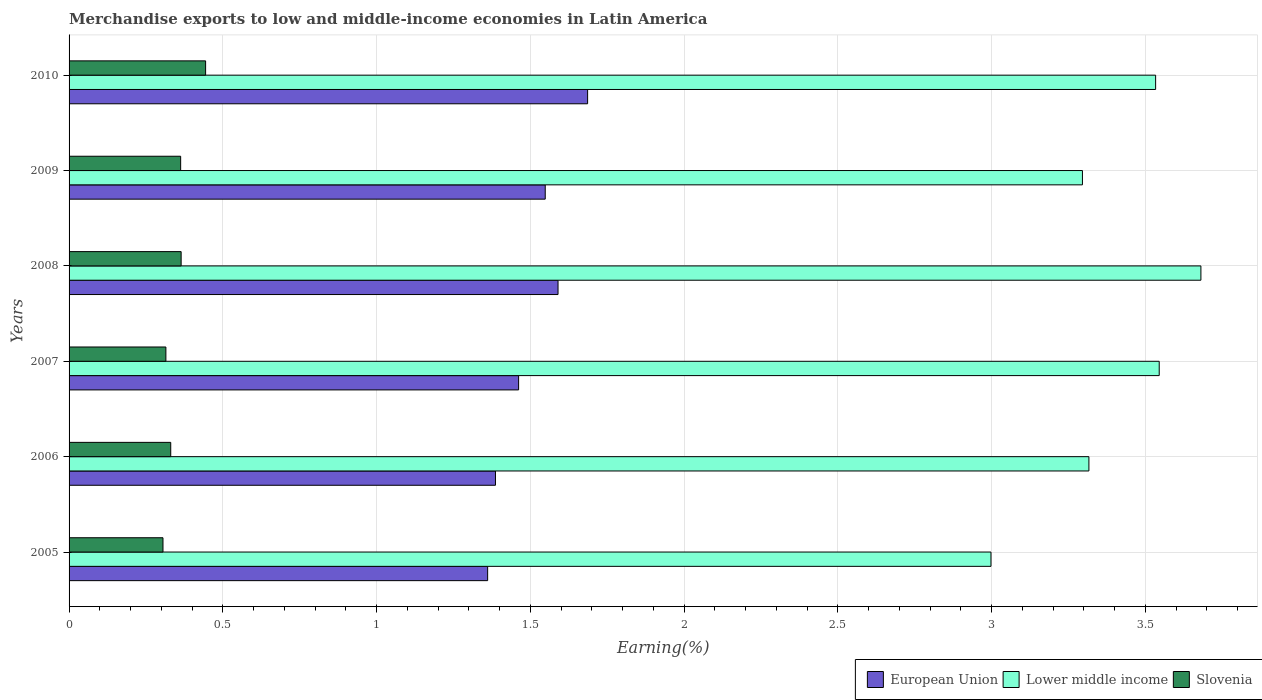How many bars are there on the 1st tick from the top?
Offer a terse response. 3. What is the label of the 6th group of bars from the top?
Keep it short and to the point. 2005. What is the percentage of amount earned from merchandise exports in European Union in 2007?
Your answer should be very brief. 1.46. Across all years, what is the maximum percentage of amount earned from merchandise exports in Slovenia?
Your response must be concise. 0.44. Across all years, what is the minimum percentage of amount earned from merchandise exports in Lower middle income?
Offer a very short reply. 3. What is the total percentage of amount earned from merchandise exports in Slovenia in the graph?
Offer a very short reply. 2.12. What is the difference between the percentage of amount earned from merchandise exports in Lower middle income in 2005 and that in 2008?
Your response must be concise. -0.68. What is the difference between the percentage of amount earned from merchandise exports in Slovenia in 2010 and the percentage of amount earned from merchandise exports in Lower middle income in 2009?
Ensure brevity in your answer.  -2.85. What is the average percentage of amount earned from merchandise exports in European Union per year?
Offer a terse response. 1.51. In the year 2010, what is the difference between the percentage of amount earned from merchandise exports in Lower middle income and percentage of amount earned from merchandise exports in Slovenia?
Offer a very short reply. 3.09. In how many years, is the percentage of amount earned from merchandise exports in European Union greater than 2.2 %?
Ensure brevity in your answer.  0. What is the ratio of the percentage of amount earned from merchandise exports in Lower middle income in 2009 to that in 2010?
Your response must be concise. 0.93. Is the difference between the percentage of amount earned from merchandise exports in Lower middle income in 2006 and 2008 greater than the difference between the percentage of amount earned from merchandise exports in Slovenia in 2006 and 2008?
Your answer should be very brief. No. What is the difference between the highest and the second highest percentage of amount earned from merchandise exports in Slovenia?
Give a very brief answer. 0.08. What is the difference between the highest and the lowest percentage of amount earned from merchandise exports in Lower middle income?
Your response must be concise. 0.68. In how many years, is the percentage of amount earned from merchandise exports in European Union greater than the average percentage of amount earned from merchandise exports in European Union taken over all years?
Keep it short and to the point. 3. What does the 2nd bar from the top in 2008 represents?
Your answer should be compact. Lower middle income. What does the 3rd bar from the bottom in 2007 represents?
Your answer should be very brief. Slovenia. Is it the case that in every year, the sum of the percentage of amount earned from merchandise exports in Slovenia and percentage of amount earned from merchandise exports in Lower middle income is greater than the percentage of amount earned from merchandise exports in European Union?
Provide a short and direct response. Yes. What is the difference between two consecutive major ticks on the X-axis?
Give a very brief answer. 0.5. Does the graph contain any zero values?
Your answer should be compact. No. Where does the legend appear in the graph?
Give a very brief answer. Bottom right. How many legend labels are there?
Keep it short and to the point. 3. What is the title of the graph?
Give a very brief answer. Merchandise exports to low and middle-income economies in Latin America. Does "Monaco" appear as one of the legend labels in the graph?
Your answer should be compact. No. What is the label or title of the X-axis?
Provide a succinct answer. Earning(%). What is the Earning(%) of European Union in 2005?
Provide a short and direct response. 1.36. What is the Earning(%) of Lower middle income in 2005?
Your answer should be compact. 3. What is the Earning(%) of Slovenia in 2005?
Provide a succinct answer. 0.31. What is the Earning(%) in European Union in 2006?
Your answer should be compact. 1.39. What is the Earning(%) in Lower middle income in 2006?
Keep it short and to the point. 3.32. What is the Earning(%) of Slovenia in 2006?
Your answer should be compact. 0.33. What is the Earning(%) of European Union in 2007?
Ensure brevity in your answer.  1.46. What is the Earning(%) of Lower middle income in 2007?
Offer a very short reply. 3.55. What is the Earning(%) of Slovenia in 2007?
Your answer should be compact. 0.31. What is the Earning(%) of European Union in 2008?
Offer a terse response. 1.59. What is the Earning(%) of Lower middle income in 2008?
Provide a short and direct response. 3.68. What is the Earning(%) in Slovenia in 2008?
Give a very brief answer. 0.36. What is the Earning(%) in European Union in 2009?
Ensure brevity in your answer.  1.55. What is the Earning(%) of Lower middle income in 2009?
Your answer should be very brief. 3.3. What is the Earning(%) in Slovenia in 2009?
Give a very brief answer. 0.36. What is the Earning(%) of European Union in 2010?
Offer a very short reply. 1.69. What is the Earning(%) in Lower middle income in 2010?
Provide a succinct answer. 3.53. What is the Earning(%) of Slovenia in 2010?
Provide a succinct answer. 0.44. Across all years, what is the maximum Earning(%) in European Union?
Your answer should be compact. 1.69. Across all years, what is the maximum Earning(%) of Lower middle income?
Provide a succinct answer. 3.68. Across all years, what is the maximum Earning(%) in Slovenia?
Offer a very short reply. 0.44. Across all years, what is the minimum Earning(%) of European Union?
Make the answer very short. 1.36. Across all years, what is the minimum Earning(%) in Lower middle income?
Offer a very short reply. 3. Across all years, what is the minimum Earning(%) in Slovenia?
Offer a very short reply. 0.31. What is the total Earning(%) of European Union in the graph?
Provide a succinct answer. 9.04. What is the total Earning(%) of Lower middle income in the graph?
Make the answer very short. 20.37. What is the total Earning(%) in Slovenia in the graph?
Offer a terse response. 2.12. What is the difference between the Earning(%) in European Union in 2005 and that in 2006?
Provide a succinct answer. -0.03. What is the difference between the Earning(%) of Lower middle income in 2005 and that in 2006?
Provide a short and direct response. -0.32. What is the difference between the Earning(%) of Slovenia in 2005 and that in 2006?
Ensure brevity in your answer.  -0.03. What is the difference between the Earning(%) of European Union in 2005 and that in 2007?
Provide a succinct answer. -0.1. What is the difference between the Earning(%) in Lower middle income in 2005 and that in 2007?
Your answer should be very brief. -0.55. What is the difference between the Earning(%) in Slovenia in 2005 and that in 2007?
Keep it short and to the point. -0.01. What is the difference between the Earning(%) of European Union in 2005 and that in 2008?
Your response must be concise. -0.23. What is the difference between the Earning(%) of Lower middle income in 2005 and that in 2008?
Your answer should be compact. -0.68. What is the difference between the Earning(%) in Slovenia in 2005 and that in 2008?
Your response must be concise. -0.06. What is the difference between the Earning(%) of European Union in 2005 and that in 2009?
Your answer should be very brief. -0.19. What is the difference between the Earning(%) in Lower middle income in 2005 and that in 2009?
Ensure brevity in your answer.  -0.3. What is the difference between the Earning(%) of Slovenia in 2005 and that in 2009?
Your answer should be very brief. -0.06. What is the difference between the Earning(%) of European Union in 2005 and that in 2010?
Ensure brevity in your answer.  -0.33. What is the difference between the Earning(%) in Lower middle income in 2005 and that in 2010?
Your response must be concise. -0.54. What is the difference between the Earning(%) in Slovenia in 2005 and that in 2010?
Provide a succinct answer. -0.14. What is the difference between the Earning(%) in European Union in 2006 and that in 2007?
Make the answer very short. -0.08. What is the difference between the Earning(%) of Lower middle income in 2006 and that in 2007?
Ensure brevity in your answer.  -0.23. What is the difference between the Earning(%) of Slovenia in 2006 and that in 2007?
Provide a succinct answer. 0.02. What is the difference between the Earning(%) of European Union in 2006 and that in 2008?
Give a very brief answer. -0.2. What is the difference between the Earning(%) in Lower middle income in 2006 and that in 2008?
Ensure brevity in your answer.  -0.36. What is the difference between the Earning(%) in Slovenia in 2006 and that in 2008?
Provide a succinct answer. -0.03. What is the difference between the Earning(%) of European Union in 2006 and that in 2009?
Your answer should be compact. -0.16. What is the difference between the Earning(%) in Lower middle income in 2006 and that in 2009?
Keep it short and to the point. 0.02. What is the difference between the Earning(%) in Slovenia in 2006 and that in 2009?
Your answer should be compact. -0.03. What is the difference between the Earning(%) of European Union in 2006 and that in 2010?
Ensure brevity in your answer.  -0.3. What is the difference between the Earning(%) in Lower middle income in 2006 and that in 2010?
Give a very brief answer. -0.22. What is the difference between the Earning(%) in Slovenia in 2006 and that in 2010?
Your response must be concise. -0.11. What is the difference between the Earning(%) of European Union in 2007 and that in 2008?
Ensure brevity in your answer.  -0.13. What is the difference between the Earning(%) of Lower middle income in 2007 and that in 2008?
Your response must be concise. -0.14. What is the difference between the Earning(%) of Slovenia in 2007 and that in 2008?
Provide a succinct answer. -0.05. What is the difference between the Earning(%) of European Union in 2007 and that in 2009?
Your answer should be very brief. -0.09. What is the difference between the Earning(%) in Lower middle income in 2007 and that in 2009?
Provide a short and direct response. 0.25. What is the difference between the Earning(%) in Slovenia in 2007 and that in 2009?
Offer a terse response. -0.05. What is the difference between the Earning(%) in European Union in 2007 and that in 2010?
Your response must be concise. -0.22. What is the difference between the Earning(%) in Lower middle income in 2007 and that in 2010?
Ensure brevity in your answer.  0.01. What is the difference between the Earning(%) in Slovenia in 2007 and that in 2010?
Provide a succinct answer. -0.13. What is the difference between the Earning(%) of European Union in 2008 and that in 2009?
Offer a very short reply. 0.04. What is the difference between the Earning(%) of Lower middle income in 2008 and that in 2009?
Offer a very short reply. 0.39. What is the difference between the Earning(%) in Slovenia in 2008 and that in 2009?
Your answer should be very brief. 0. What is the difference between the Earning(%) of European Union in 2008 and that in 2010?
Make the answer very short. -0.1. What is the difference between the Earning(%) in Lower middle income in 2008 and that in 2010?
Provide a short and direct response. 0.15. What is the difference between the Earning(%) of Slovenia in 2008 and that in 2010?
Your response must be concise. -0.08. What is the difference between the Earning(%) of European Union in 2009 and that in 2010?
Provide a succinct answer. -0.14. What is the difference between the Earning(%) of Lower middle income in 2009 and that in 2010?
Give a very brief answer. -0.24. What is the difference between the Earning(%) of Slovenia in 2009 and that in 2010?
Offer a terse response. -0.08. What is the difference between the Earning(%) in European Union in 2005 and the Earning(%) in Lower middle income in 2006?
Provide a short and direct response. -1.96. What is the difference between the Earning(%) of European Union in 2005 and the Earning(%) of Slovenia in 2006?
Offer a very short reply. 1.03. What is the difference between the Earning(%) in Lower middle income in 2005 and the Earning(%) in Slovenia in 2006?
Your answer should be compact. 2.67. What is the difference between the Earning(%) in European Union in 2005 and the Earning(%) in Lower middle income in 2007?
Offer a terse response. -2.18. What is the difference between the Earning(%) of European Union in 2005 and the Earning(%) of Slovenia in 2007?
Your answer should be very brief. 1.05. What is the difference between the Earning(%) of Lower middle income in 2005 and the Earning(%) of Slovenia in 2007?
Offer a terse response. 2.68. What is the difference between the Earning(%) of European Union in 2005 and the Earning(%) of Lower middle income in 2008?
Your response must be concise. -2.32. What is the difference between the Earning(%) of Lower middle income in 2005 and the Earning(%) of Slovenia in 2008?
Offer a very short reply. 2.63. What is the difference between the Earning(%) of European Union in 2005 and the Earning(%) of Lower middle income in 2009?
Offer a very short reply. -1.93. What is the difference between the Earning(%) in Lower middle income in 2005 and the Earning(%) in Slovenia in 2009?
Offer a very short reply. 2.64. What is the difference between the Earning(%) of European Union in 2005 and the Earning(%) of Lower middle income in 2010?
Provide a succinct answer. -2.17. What is the difference between the Earning(%) of European Union in 2005 and the Earning(%) of Slovenia in 2010?
Give a very brief answer. 0.92. What is the difference between the Earning(%) in Lower middle income in 2005 and the Earning(%) in Slovenia in 2010?
Offer a very short reply. 2.55. What is the difference between the Earning(%) in European Union in 2006 and the Earning(%) in Lower middle income in 2007?
Keep it short and to the point. -2.16. What is the difference between the Earning(%) of European Union in 2006 and the Earning(%) of Slovenia in 2007?
Ensure brevity in your answer.  1.07. What is the difference between the Earning(%) in Lower middle income in 2006 and the Earning(%) in Slovenia in 2007?
Make the answer very short. 3. What is the difference between the Earning(%) in European Union in 2006 and the Earning(%) in Lower middle income in 2008?
Provide a short and direct response. -2.29. What is the difference between the Earning(%) of European Union in 2006 and the Earning(%) of Slovenia in 2008?
Your answer should be compact. 1.02. What is the difference between the Earning(%) of Lower middle income in 2006 and the Earning(%) of Slovenia in 2008?
Offer a very short reply. 2.95. What is the difference between the Earning(%) in European Union in 2006 and the Earning(%) in Lower middle income in 2009?
Offer a terse response. -1.91. What is the difference between the Earning(%) of European Union in 2006 and the Earning(%) of Slovenia in 2009?
Ensure brevity in your answer.  1.02. What is the difference between the Earning(%) in Lower middle income in 2006 and the Earning(%) in Slovenia in 2009?
Make the answer very short. 2.95. What is the difference between the Earning(%) of European Union in 2006 and the Earning(%) of Lower middle income in 2010?
Ensure brevity in your answer.  -2.15. What is the difference between the Earning(%) in European Union in 2006 and the Earning(%) in Slovenia in 2010?
Make the answer very short. 0.94. What is the difference between the Earning(%) of Lower middle income in 2006 and the Earning(%) of Slovenia in 2010?
Your answer should be compact. 2.87. What is the difference between the Earning(%) of European Union in 2007 and the Earning(%) of Lower middle income in 2008?
Ensure brevity in your answer.  -2.22. What is the difference between the Earning(%) in European Union in 2007 and the Earning(%) in Slovenia in 2008?
Make the answer very short. 1.1. What is the difference between the Earning(%) in Lower middle income in 2007 and the Earning(%) in Slovenia in 2008?
Provide a succinct answer. 3.18. What is the difference between the Earning(%) in European Union in 2007 and the Earning(%) in Lower middle income in 2009?
Make the answer very short. -1.83. What is the difference between the Earning(%) in European Union in 2007 and the Earning(%) in Slovenia in 2009?
Make the answer very short. 1.1. What is the difference between the Earning(%) of Lower middle income in 2007 and the Earning(%) of Slovenia in 2009?
Offer a terse response. 3.18. What is the difference between the Earning(%) in European Union in 2007 and the Earning(%) in Lower middle income in 2010?
Keep it short and to the point. -2.07. What is the difference between the Earning(%) in European Union in 2007 and the Earning(%) in Slovenia in 2010?
Offer a terse response. 1.02. What is the difference between the Earning(%) of Lower middle income in 2007 and the Earning(%) of Slovenia in 2010?
Provide a succinct answer. 3.1. What is the difference between the Earning(%) in European Union in 2008 and the Earning(%) in Lower middle income in 2009?
Offer a terse response. -1.71. What is the difference between the Earning(%) of European Union in 2008 and the Earning(%) of Slovenia in 2009?
Keep it short and to the point. 1.23. What is the difference between the Earning(%) of Lower middle income in 2008 and the Earning(%) of Slovenia in 2009?
Give a very brief answer. 3.32. What is the difference between the Earning(%) of European Union in 2008 and the Earning(%) of Lower middle income in 2010?
Provide a short and direct response. -1.94. What is the difference between the Earning(%) in European Union in 2008 and the Earning(%) in Slovenia in 2010?
Give a very brief answer. 1.15. What is the difference between the Earning(%) of Lower middle income in 2008 and the Earning(%) of Slovenia in 2010?
Provide a succinct answer. 3.24. What is the difference between the Earning(%) of European Union in 2009 and the Earning(%) of Lower middle income in 2010?
Provide a short and direct response. -1.99. What is the difference between the Earning(%) in European Union in 2009 and the Earning(%) in Slovenia in 2010?
Offer a very short reply. 1.1. What is the difference between the Earning(%) of Lower middle income in 2009 and the Earning(%) of Slovenia in 2010?
Keep it short and to the point. 2.85. What is the average Earning(%) of European Union per year?
Give a very brief answer. 1.51. What is the average Earning(%) in Lower middle income per year?
Make the answer very short. 3.4. What is the average Earning(%) in Slovenia per year?
Give a very brief answer. 0.35. In the year 2005, what is the difference between the Earning(%) in European Union and Earning(%) in Lower middle income?
Keep it short and to the point. -1.64. In the year 2005, what is the difference between the Earning(%) of European Union and Earning(%) of Slovenia?
Your answer should be very brief. 1.06. In the year 2005, what is the difference between the Earning(%) of Lower middle income and Earning(%) of Slovenia?
Keep it short and to the point. 2.69. In the year 2006, what is the difference between the Earning(%) in European Union and Earning(%) in Lower middle income?
Provide a short and direct response. -1.93. In the year 2006, what is the difference between the Earning(%) of European Union and Earning(%) of Slovenia?
Give a very brief answer. 1.06. In the year 2006, what is the difference between the Earning(%) in Lower middle income and Earning(%) in Slovenia?
Make the answer very short. 2.99. In the year 2007, what is the difference between the Earning(%) in European Union and Earning(%) in Lower middle income?
Keep it short and to the point. -2.08. In the year 2007, what is the difference between the Earning(%) of European Union and Earning(%) of Slovenia?
Give a very brief answer. 1.15. In the year 2007, what is the difference between the Earning(%) of Lower middle income and Earning(%) of Slovenia?
Offer a terse response. 3.23. In the year 2008, what is the difference between the Earning(%) in European Union and Earning(%) in Lower middle income?
Keep it short and to the point. -2.09. In the year 2008, what is the difference between the Earning(%) in European Union and Earning(%) in Slovenia?
Keep it short and to the point. 1.23. In the year 2008, what is the difference between the Earning(%) in Lower middle income and Earning(%) in Slovenia?
Your answer should be compact. 3.32. In the year 2009, what is the difference between the Earning(%) of European Union and Earning(%) of Lower middle income?
Your answer should be very brief. -1.75. In the year 2009, what is the difference between the Earning(%) of European Union and Earning(%) of Slovenia?
Keep it short and to the point. 1.19. In the year 2009, what is the difference between the Earning(%) in Lower middle income and Earning(%) in Slovenia?
Offer a terse response. 2.93. In the year 2010, what is the difference between the Earning(%) of European Union and Earning(%) of Lower middle income?
Offer a terse response. -1.85. In the year 2010, what is the difference between the Earning(%) of European Union and Earning(%) of Slovenia?
Provide a succinct answer. 1.24. In the year 2010, what is the difference between the Earning(%) of Lower middle income and Earning(%) of Slovenia?
Provide a short and direct response. 3.09. What is the ratio of the Earning(%) in European Union in 2005 to that in 2006?
Provide a short and direct response. 0.98. What is the ratio of the Earning(%) of Lower middle income in 2005 to that in 2006?
Provide a short and direct response. 0.9. What is the ratio of the Earning(%) of Slovenia in 2005 to that in 2006?
Keep it short and to the point. 0.92. What is the ratio of the Earning(%) in European Union in 2005 to that in 2007?
Make the answer very short. 0.93. What is the ratio of the Earning(%) in Lower middle income in 2005 to that in 2007?
Ensure brevity in your answer.  0.85. What is the ratio of the Earning(%) of Slovenia in 2005 to that in 2007?
Keep it short and to the point. 0.97. What is the ratio of the Earning(%) of European Union in 2005 to that in 2008?
Give a very brief answer. 0.86. What is the ratio of the Earning(%) in Lower middle income in 2005 to that in 2008?
Provide a succinct answer. 0.81. What is the ratio of the Earning(%) of Slovenia in 2005 to that in 2008?
Make the answer very short. 0.84. What is the ratio of the Earning(%) in European Union in 2005 to that in 2009?
Your answer should be very brief. 0.88. What is the ratio of the Earning(%) of Lower middle income in 2005 to that in 2009?
Provide a short and direct response. 0.91. What is the ratio of the Earning(%) in Slovenia in 2005 to that in 2009?
Provide a succinct answer. 0.84. What is the ratio of the Earning(%) in European Union in 2005 to that in 2010?
Offer a very short reply. 0.81. What is the ratio of the Earning(%) of Lower middle income in 2005 to that in 2010?
Make the answer very short. 0.85. What is the ratio of the Earning(%) in Slovenia in 2005 to that in 2010?
Offer a terse response. 0.69. What is the ratio of the Earning(%) of European Union in 2006 to that in 2007?
Provide a succinct answer. 0.95. What is the ratio of the Earning(%) of Lower middle income in 2006 to that in 2007?
Give a very brief answer. 0.94. What is the ratio of the Earning(%) of European Union in 2006 to that in 2008?
Offer a very short reply. 0.87. What is the ratio of the Earning(%) of Lower middle income in 2006 to that in 2008?
Provide a succinct answer. 0.9. What is the ratio of the Earning(%) of Slovenia in 2006 to that in 2008?
Your answer should be compact. 0.91. What is the ratio of the Earning(%) of European Union in 2006 to that in 2009?
Your response must be concise. 0.9. What is the ratio of the Earning(%) of Lower middle income in 2006 to that in 2009?
Your response must be concise. 1.01. What is the ratio of the Earning(%) in Slovenia in 2006 to that in 2009?
Provide a succinct answer. 0.91. What is the ratio of the Earning(%) in European Union in 2006 to that in 2010?
Your answer should be compact. 0.82. What is the ratio of the Earning(%) of Lower middle income in 2006 to that in 2010?
Your response must be concise. 0.94. What is the ratio of the Earning(%) in Slovenia in 2006 to that in 2010?
Ensure brevity in your answer.  0.74. What is the ratio of the Earning(%) of European Union in 2007 to that in 2008?
Make the answer very short. 0.92. What is the ratio of the Earning(%) in Lower middle income in 2007 to that in 2008?
Provide a short and direct response. 0.96. What is the ratio of the Earning(%) of Slovenia in 2007 to that in 2008?
Your answer should be compact. 0.86. What is the ratio of the Earning(%) in European Union in 2007 to that in 2009?
Offer a very short reply. 0.94. What is the ratio of the Earning(%) of Lower middle income in 2007 to that in 2009?
Ensure brevity in your answer.  1.08. What is the ratio of the Earning(%) in Slovenia in 2007 to that in 2009?
Give a very brief answer. 0.87. What is the ratio of the Earning(%) of European Union in 2007 to that in 2010?
Keep it short and to the point. 0.87. What is the ratio of the Earning(%) in Slovenia in 2007 to that in 2010?
Offer a terse response. 0.71. What is the ratio of the Earning(%) in European Union in 2008 to that in 2009?
Your answer should be compact. 1.03. What is the ratio of the Earning(%) in Lower middle income in 2008 to that in 2009?
Give a very brief answer. 1.12. What is the ratio of the Earning(%) in Slovenia in 2008 to that in 2009?
Ensure brevity in your answer.  1. What is the ratio of the Earning(%) of European Union in 2008 to that in 2010?
Your response must be concise. 0.94. What is the ratio of the Earning(%) of Lower middle income in 2008 to that in 2010?
Offer a very short reply. 1.04. What is the ratio of the Earning(%) of Slovenia in 2008 to that in 2010?
Provide a short and direct response. 0.82. What is the ratio of the Earning(%) in European Union in 2009 to that in 2010?
Offer a very short reply. 0.92. What is the ratio of the Earning(%) in Lower middle income in 2009 to that in 2010?
Keep it short and to the point. 0.93. What is the ratio of the Earning(%) of Slovenia in 2009 to that in 2010?
Make the answer very short. 0.82. What is the difference between the highest and the second highest Earning(%) in European Union?
Give a very brief answer. 0.1. What is the difference between the highest and the second highest Earning(%) of Lower middle income?
Give a very brief answer. 0.14. What is the difference between the highest and the second highest Earning(%) in Slovenia?
Make the answer very short. 0.08. What is the difference between the highest and the lowest Earning(%) in European Union?
Give a very brief answer. 0.33. What is the difference between the highest and the lowest Earning(%) in Lower middle income?
Provide a succinct answer. 0.68. What is the difference between the highest and the lowest Earning(%) in Slovenia?
Provide a succinct answer. 0.14. 